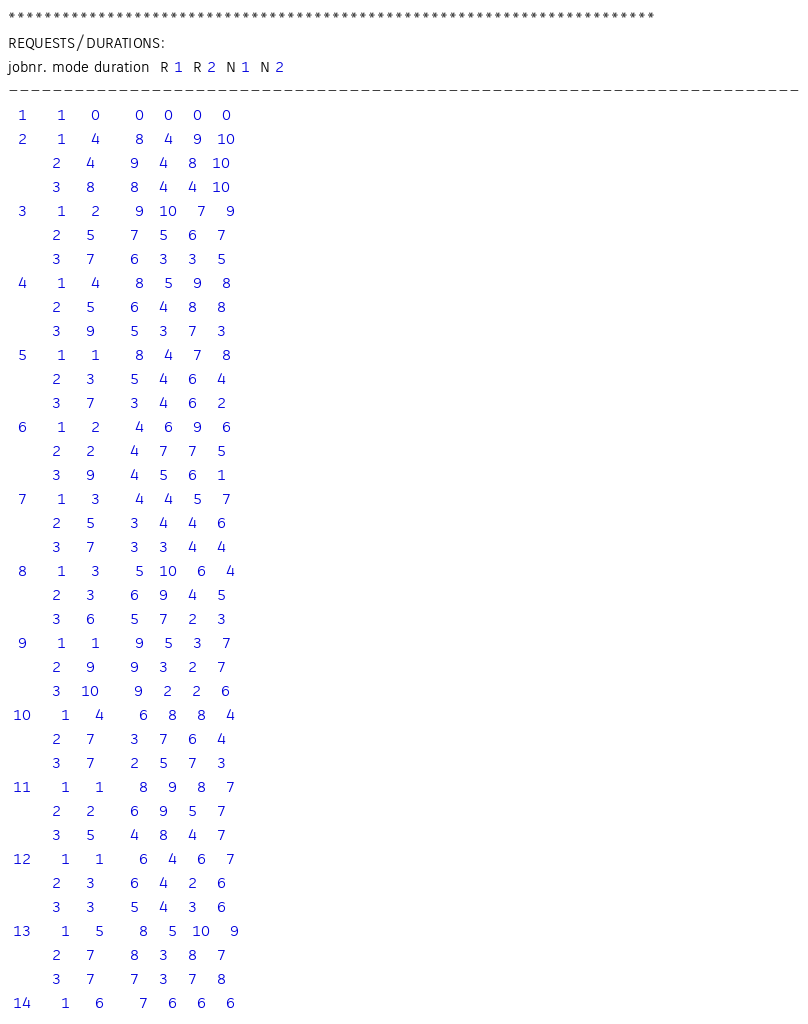Convert code to text. <code><loc_0><loc_0><loc_500><loc_500><_ObjectiveC_>************************************************************************
REQUESTS/DURATIONS:
jobnr. mode duration  R 1  R 2  N 1  N 2
------------------------------------------------------------------------
  1      1     0       0    0    0    0
  2      1     4       8    4    9   10
         2     4       9    4    8   10
         3     8       8    4    4   10
  3      1     2       9   10    7    9
         2     5       7    5    6    7
         3     7       6    3    3    5
  4      1     4       8    5    9    8
         2     5       6    4    8    8
         3     9       5    3    7    3
  5      1     1       8    4    7    8
         2     3       5    4    6    4
         3     7       3    4    6    2
  6      1     2       4    6    9    6
         2     2       4    7    7    5
         3     9       4    5    6    1
  7      1     3       4    4    5    7
         2     5       3    4    4    6
         3     7       3    3    4    4
  8      1     3       5   10    6    4
         2     3       6    9    4    5
         3     6       5    7    2    3
  9      1     1       9    5    3    7
         2     9       9    3    2    7
         3    10       9    2    2    6
 10      1     4       6    8    8    4
         2     7       3    7    6    4
         3     7       2    5    7    3
 11      1     1       8    9    8    7
         2     2       6    9    5    7
         3     5       4    8    4    7
 12      1     1       6    4    6    7
         2     3       6    4    2    6
         3     3       5    4    3    6
 13      1     5       8    5   10    9
         2     7       8    3    8    7
         3     7       7    3    7    8
 14      1     6       7    6    6    6</code> 